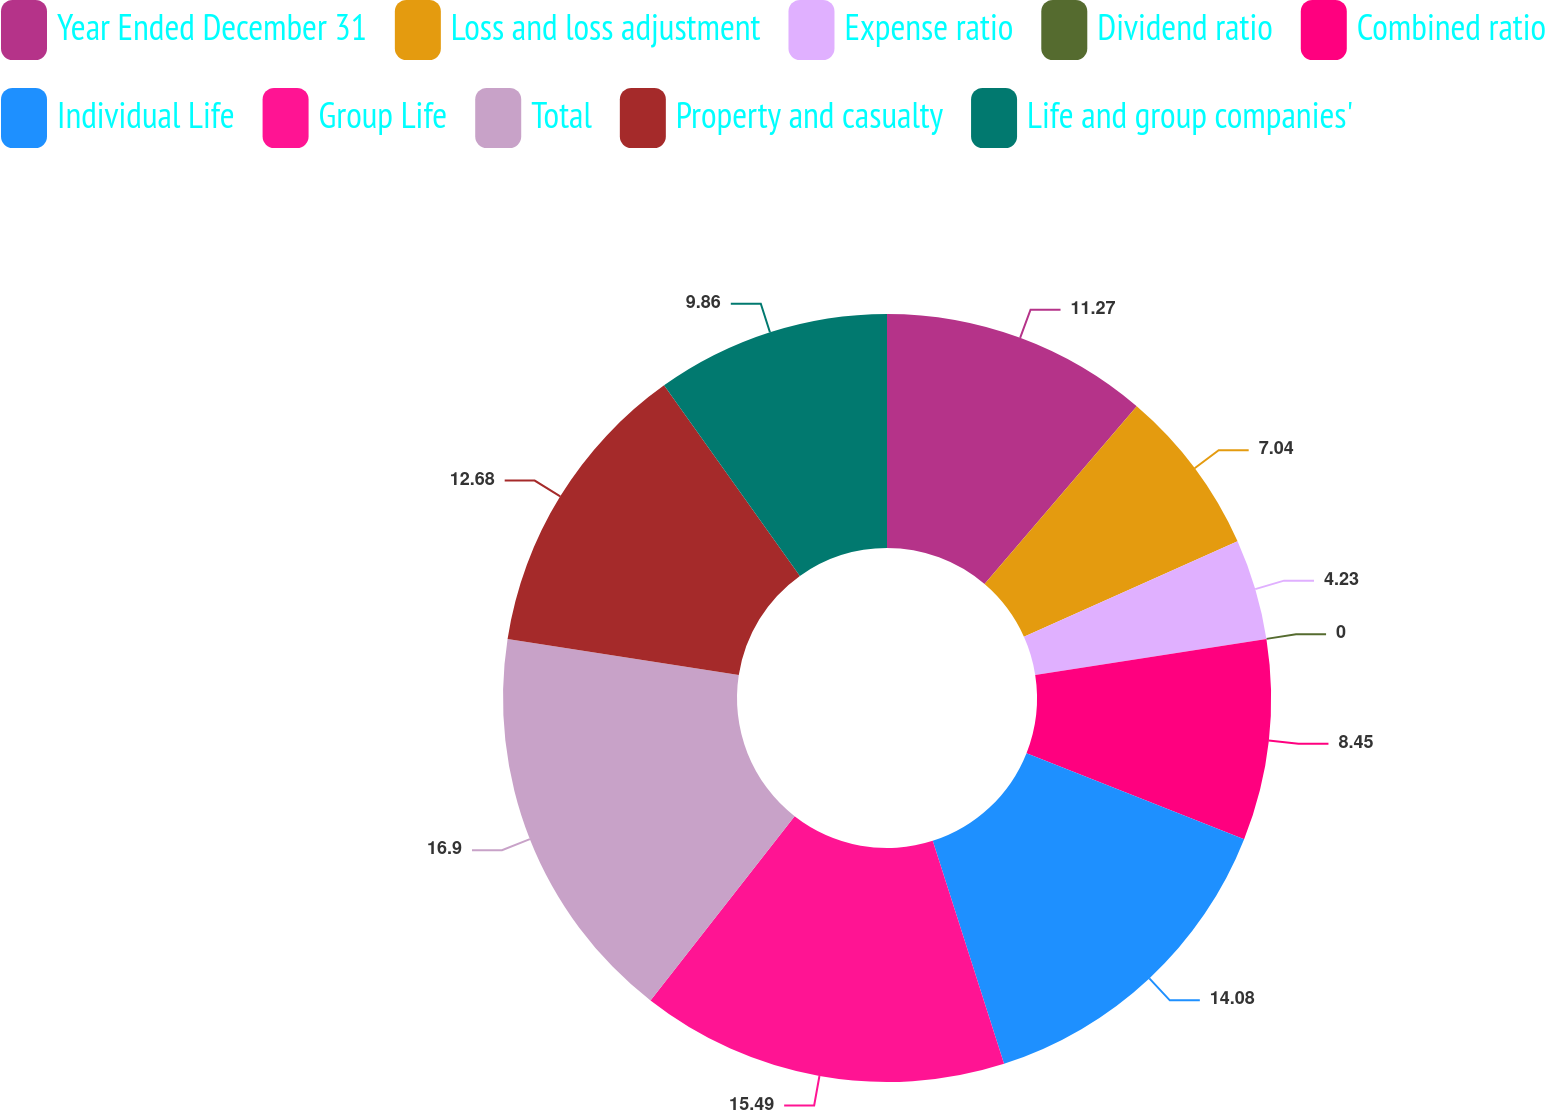<chart> <loc_0><loc_0><loc_500><loc_500><pie_chart><fcel>Year Ended December 31<fcel>Loss and loss adjustment<fcel>Expense ratio<fcel>Dividend ratio<fcel>Combined ratio<fcel>Individual Life<fcel>Group Life<fcel>Total<fcel>Property and casualty<fcel>Life and group companies'<nl><fcel>11.27%<fcel>7.04%<fcel>4.23%<fcel>0.0%<fcel>8.45%<fcel>14.08%<fcel>15.49%<fcel>16.9%<fcel>12.68%<fcel>9.86%<nl></chart> 